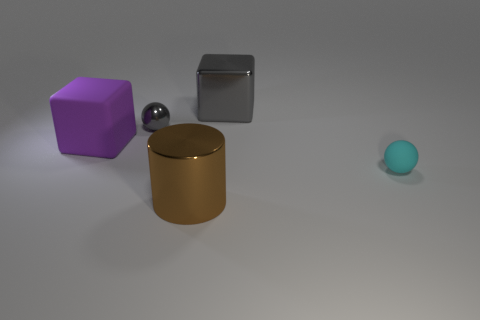What size is the metallic thing that is to the left of the large cylinder in front of the small thing that is in front of the purple cube?
Provide a succinct answer. Small. Are there any small gray objects?
Offer a terse response. Yes. There is a sphere that is the same color as the large metal cube; what is it made of?
Make the answer very short. Metal. How many big cubes are the same color as the metal ball?
Your response must be concise. 1. What number of objects are things that are left of the brown metal thing or large cubes that are right of the big purple matte cube?
Your response must be concise. 3. There is a block right of the large cylinder; what number of cyan rubber things are in front of it?
Keep it short and to the point. 1. There is a block that is the same material as the small cyan ball; what color is it?
Ensure brevity in your answer.  Purple. Are there any red metallic things that have the same size as the cyan rubber thing?
Your answer should be compact. No. There is a purple matte object that is the same size as the brown cylinder; what is its shape?
Give a very brief answer. Cube. Is there a yellow object that has the same shape as the purple thing?
Your answer should be very brief. No. 